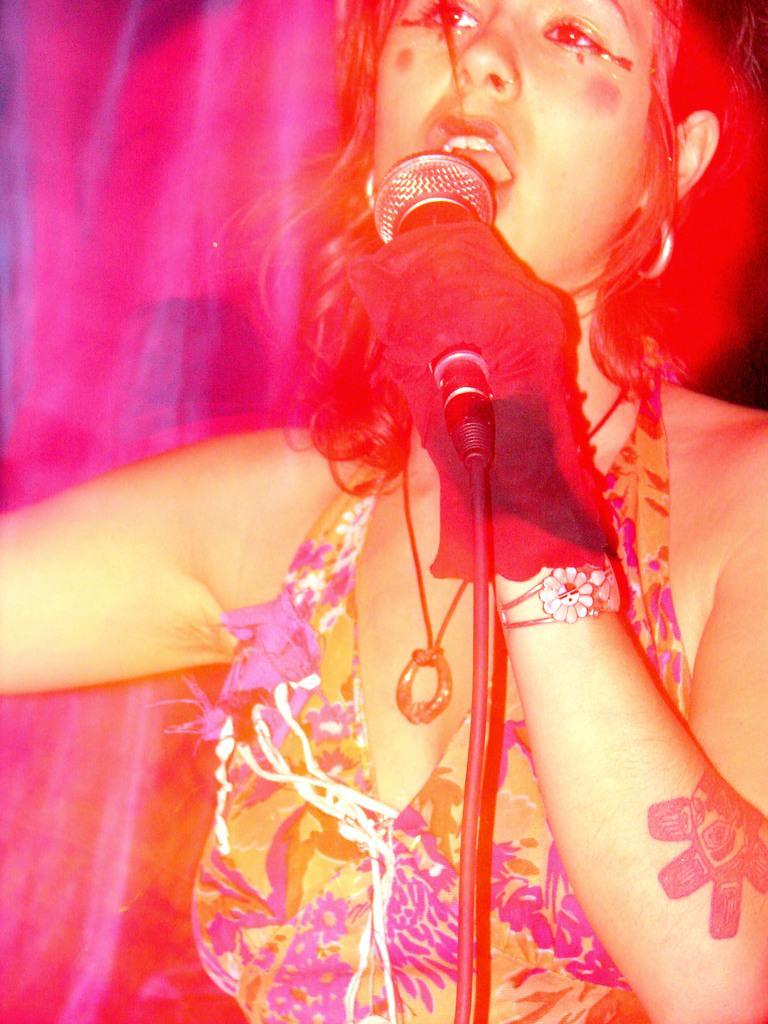Can you describe this image briefly? In this image there is a woman standing and singing a song using the mike. This is the mike stand. 